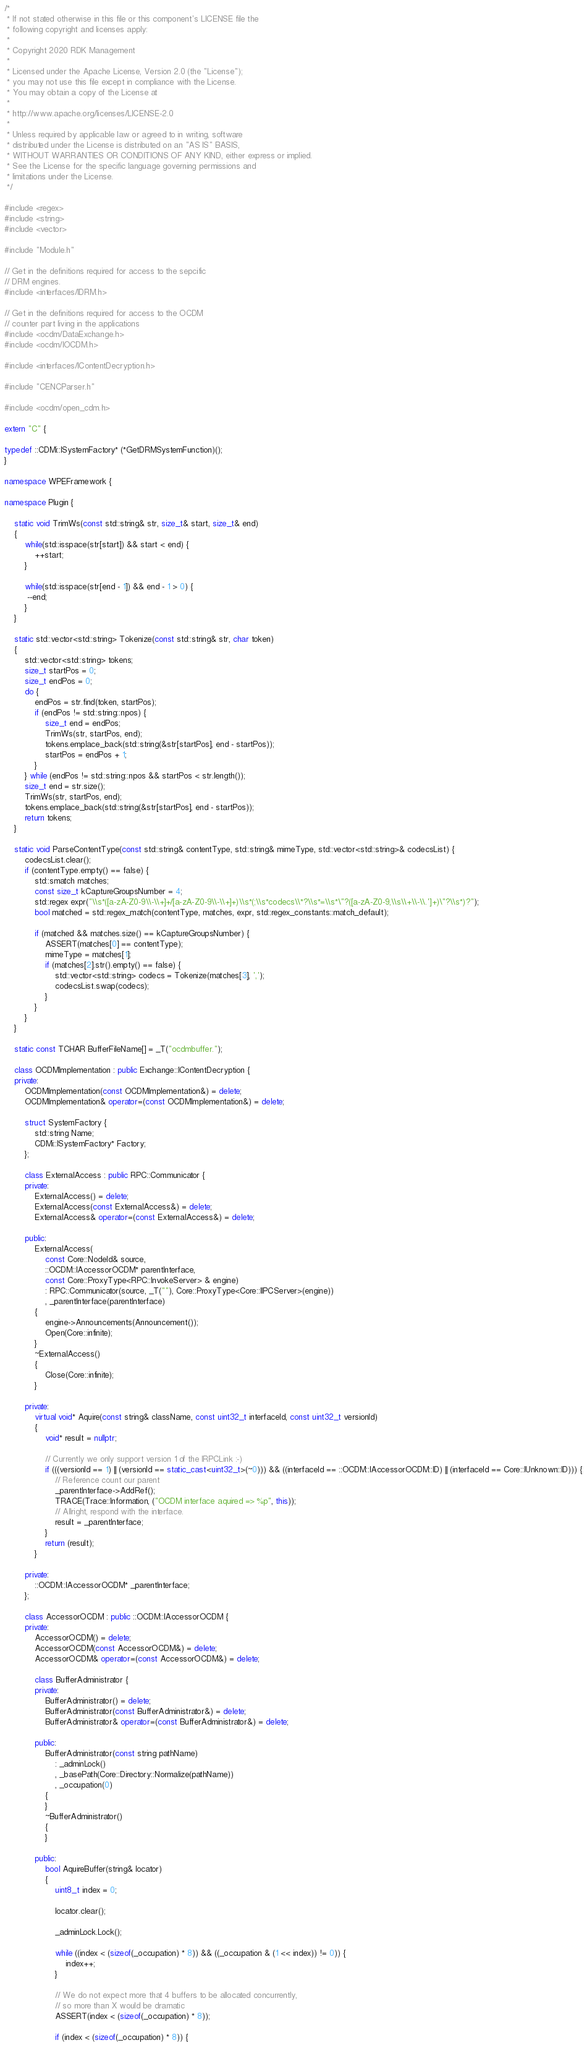<code> <loc_0><loc_0><loc_500><loc_500><_C++_>/*
 * If not stated otherwise in this file or this component's LICENSE file the
 * following copyright and licenses apply:
 *
 * Copyright 2020 RDK Management
 *
 * Licensed under the Apache License, Version 2.0 (the "License");
 * you may not use this file except in compliance with the License.
 * You may obtain a copy of the License at
 *
 * http://www.apache.org/licenses/LICENSE-2.0
 *
 * Unless required by applicable law or agreed to in writing, software
 * distributed under the License is distributed on an "AS IS" BASIS,
 * WITHOUT WARRANTIES OR CONDITIONS OF ANY KIND, either express or implied.
 * See the License for the specific language governing permissions and
 * limitations under the License.
 */

#include <regex>
#include <string>
#include <vector>

#include "Module.h"

// Get in the definitions required for access to the sepcific
// DRM engines.
#include <interfaces/IDRM.h>

// Get in the definitions required for access to the OCDM
// counter part living in the applications
#include <ocdm/DataExchange.h>
#include <ocdm/IOCDM.h>

#include <interfaces/IContentDecryption.h>

#include "CENCParser.h"

#include <ocdm/open_cdm.h>

extern "C" {

typedef ::CDMi::ISystemFactory* (*GetDRMSystemFunction)();
}

namespace WPEFramework {

namespace Plugin {

    static void TrimWs(const std::string& str, size_t& start, size_t& end)
    {
        while(std::isspace(str[start]) && start < end) {
            ++start;
        }

        while(std::isspace(str[end - 1]) && end - 1 > 0) {
         --end;
        }
    }

    static std::vector<std::string> Tokenize(const std::string& str, char token)
    {
        std::vector<std::string> tokens;
        size_t startPos = 0;
        size_t endPos = 0;
        do {
            endPos = str.find(token, startPos);
            if (endPos != std::string::npos) {
                size_t end = endPos;
                TrimWs(str, startPos, end);
                tokens.emplace_back(std::string(&str[startPos], end - startPos));
                startPos = endPos + 1;
            }
        } while (endPos != std::string::npos && startPos < str.length());
        size_t end = str.size();
        TrimWs(str, startPos, end);
        tokens.emplace_back(std::string(&str[startPos], end - startPos));
        return tokens;
    }

    static void ParseContentType(const std::string& contentType, std::string& mimeType, std::vector<std::string>& codecsList) {
        codecsList.clear();
        if (contentType.empty() == false) {
            std::smatch matches;
            const size_t kCaptureGroupsNumber = 4;
            std::regex expr("\\s*([a-zA-Z0-9\\-\\+]+/[a-zA-Z0-9\\-\\+]+)\\s*(;\\s*codecs\\*?\\s*=\\s*\"?([a-zA-Z0-9,\\s\\+\\-\\.']+)\"?\\s*)?");
            bool matched = std::regex_match(contentType, matches, expr, std::regex_constants::match_default);

            if (matched && matches.size() == kCaptureGroupsNumber) {
                ASSERT(matches[0] == contentType);
                mimeType = matches[1];
                if (matches[2].str().empty() == false) {
                    std::vector<std::string> codecs = Tokenize(matches[3], ',');
                    codecsList.swap(codecs);
                }
            }
        }
    }

    static const TCHAR BufferFileName[] = _T("ocdmbuffer.");

    class OCDMImplementation : public Exchange::IContentDecryption {
    private:
        OCDMImplementation(const OCDMImplementation&) = delete;
        OCDMImplementation& operator=(const OCDMImplementation&) = delete;

        struct SystemFactory {
            std::string Name;
            CDMi::ISystemFactory* Factory;
        };

        class ExternalAccess : public RPC::Communicator {
        private:
            ExternalAccess() = delete;
            ExternalAccess(const ExternalAccess&) = delete;
            ExternalAccess& operator=(const ExternalAccess&) = delete;

        public:
            ExternalAccess(
                const Core::NodeId& source, 
                ::OCDM::IAccessorOCDM* parentInterface, 
                const Core::ProxyType<RPC::InvokeServer> & engine)
                : RPC::Communicator(source, _T(""), Core::ProxyType<Core::IIPCServer>(engine))
                , _parentInterface(parentInterface)
            {
                engine->Announcements(Announcement());
                Open(Core::infinite);
            }
            ~ExternalAccess()
            {
                Close(Core::infinite);
            }

        private:
            virtual void* Aquire(const string& className, const uint32_t interfaceId, const uint32_t versionId)
            {
                void* result = nullptr;

                // Currently we only support version 1 of the IRPCLink :-)
                if (((versionId == 1) || (versionId == static_cast<uint32_t>(~0))) && ((interfaceId == ::OCDM::IAccessorOCDM::ID) || (interfaceId == Core::IUnknown::ID))) {
                    // Reference count our parent
                    _parentInterface->AddRef();
                    TRACE(Trace::Information, ("OCDM interface aquired => %p", this));
                    // Allright, respond with the interface.
                    result = _parentInterface;
                }
                return (result);
            }

        private:
            ::OCDM::IAccessorOCDM* _parentInterface;
        };

        class AccessorOCDM : public ::OCDM::IAccessorOCDM {
        private:
            AccessorOCDM() = delete;
            AccessorOCDM(const AccessorOCDM&) = delete;
            AccessorOCDM& operator=(const AccessorOCDM&) = delete;

            class BufferAdministrator {
            private:
                BufferAdministrator() = delete;
                BufferAdministrator(const BufferAdministrator&) = delete;
                BufferAdministrator& operator=(const BufferAdministrator&) = delete;

            public:
                BufferAdministrator(const string pathName)
                    : _adminLock()
                    , _basePath(Core::Directory::Normalize(pathName))
                    , _occupation(0)
                {
                }
                ~BufferAdministrator()
                {
                }

            public:
                bool AquireBuffer(string& locator)
                {
                    uint8_t index = 0;

                    locator.clear();

                    _adminLock.Lock();

                    while ((index < (sizeof(_occupation) * 8)) && ((_occupation & (1 << index)) != 0)) {
                        index++;
                    }

                    // We do not expect more that 4 buffers to be allocated concurrently,
                    // so more than X would be dramatic
                    ASSERT(index < (sizeof(_occupation) * 8));

                    if (index < (sizeof(_occupation) * 8)) {</code> 